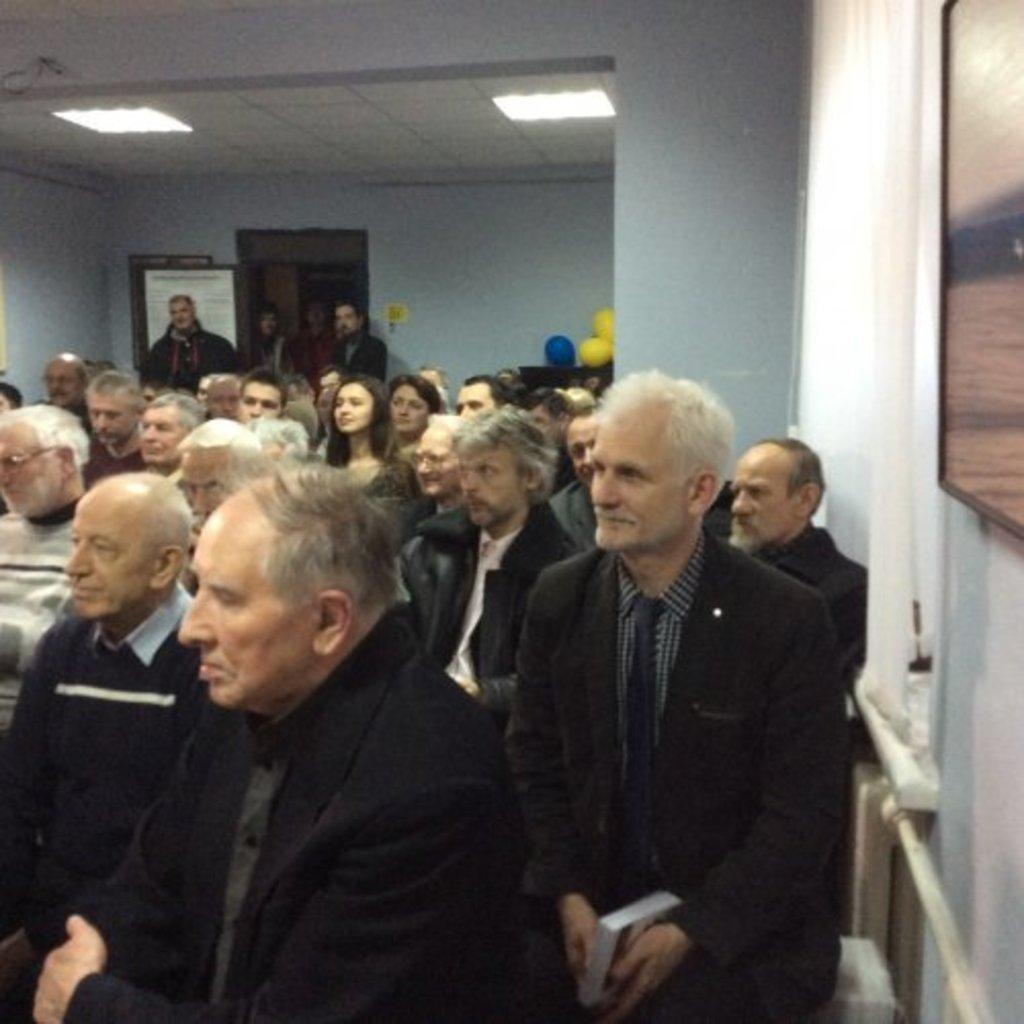What are the persons in the image doing? The persons in the image are sitting. Can you describe the people in the background of the image? There are four persons standing in the background of the image. What type of stone can be seen in the image? There is no stone present in the image; it features persons sitting and standing. 